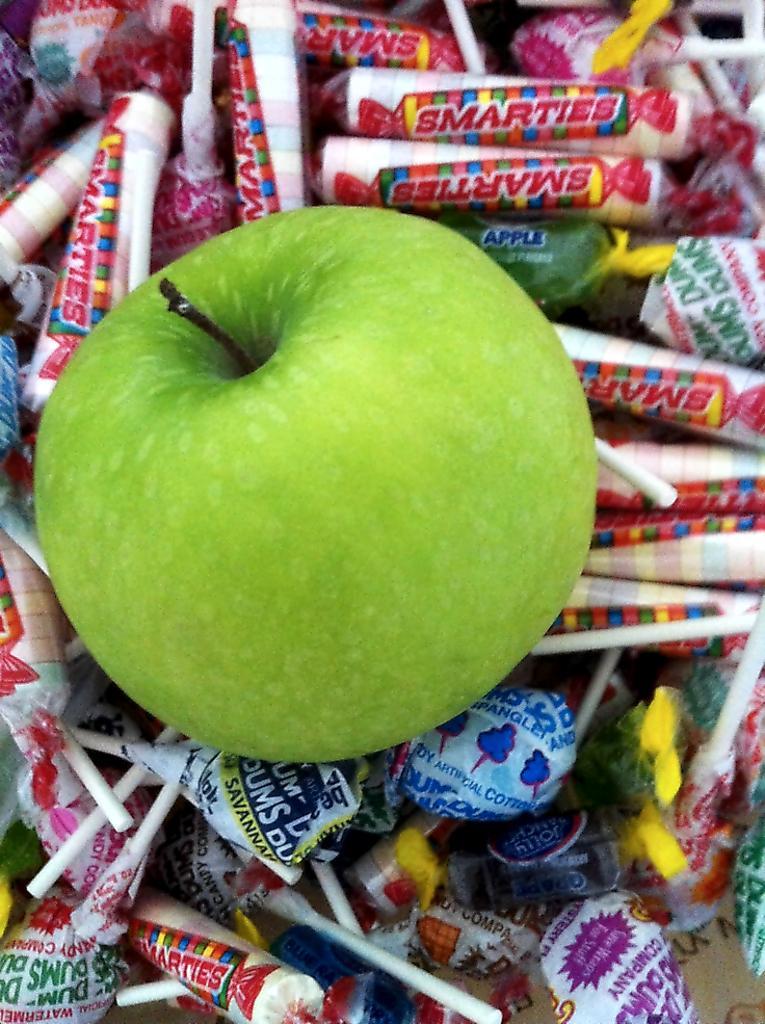How would you summarize this image in a sentence or two? In this picture we can see a green apple, few lollipops and other food items throughout the image. 